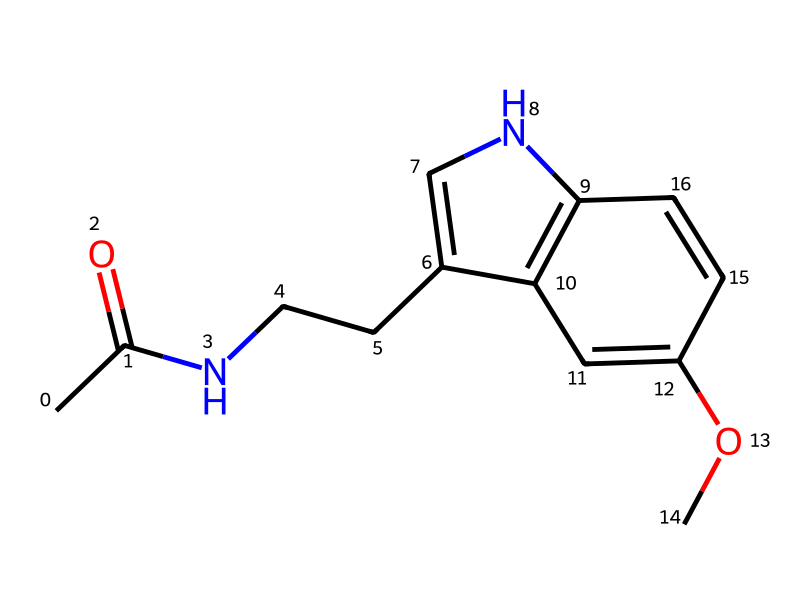What is the name of this chemical? The provided SMILES representation corresponds to the structure that is commonly identified as melatonin.
Answer: melatonin How many carbon atoms are in this molecule? By analyzing the SMILES representation, we can count the carbon atoms: there are 13 carbon atoms present.
Answer: 13 What type of chemical compound is melatonin categorized as? Melatonin is categorized as an indoleamine, which is a type of biomolecule that contains an indole ring structure and an amine group.
Answer: indoleamine How many nitrogen atoms are in melatonin? In the provided SMILES structure, we can locate the nitrogen atoms; there are 2 nitrogen atoms present in the compound.
Answer: 2 What functional group is primarily responsible for melatonin's role in regulating sleep? The acetamide functional group present in melatonin contributes to its interaction with melatonin receptors in the brain, influencing sleep regulation.
Answer: acetamide Which part of this molecule is involved in binding to receptors? The indole ring system of melatonin is vital for its activity, as it is responsible for binding to melatonin receptors in the body.
Answer: indole ring What is the molecular formula for melatonin? From the structure and counting the atoms, the molecular formula for melatonin is C13H16N2O2.
Answer: C13H16N2O2 